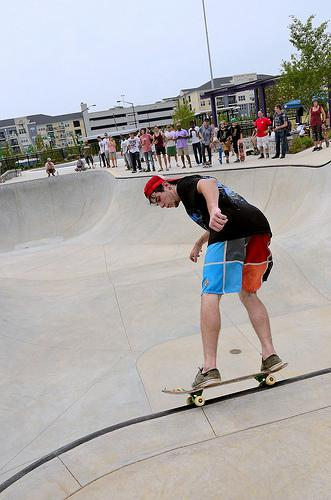Question: how many people are watching the man skate?
Choices:
A. 10.
B. 15.
C. 88.
D. 22 people.
Answer with the letter. Answer: D Question: what is the man riding?
Choices:
A. A scooter.
B. A moped.
C. A bicycle.
D. A skateboard.
Answer with the letter. Answer: D Question: when is this even taking place?
Choices:
A. At night.
B. Early morning.
C. Sunset.
D. During the day.
Answer with the letter. Answer: D Question: who is skating?
Choices:
A. A woman.
B. A girl.
C. A man.
D. A boy.
Answer with the letter. Answer: C Question: what object has four yellow wheels?
Choices:
A. A rollerskate.
B. A skateboard.
C. A rollerblade.
D. A wagon.
Answer with the letter. Answer: B 